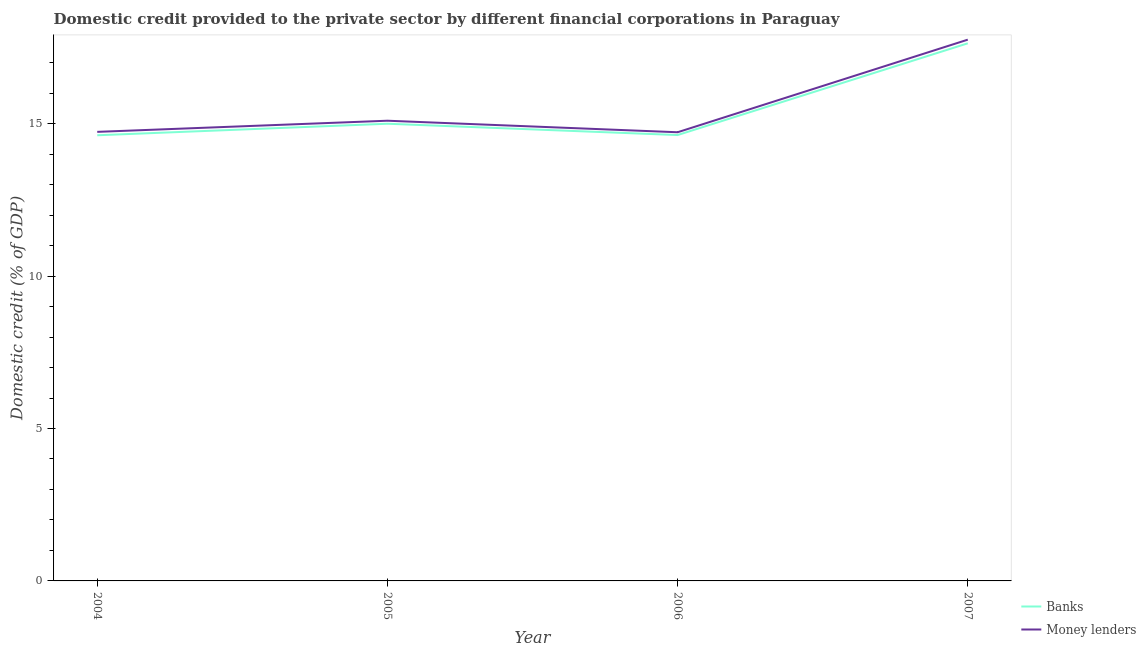How many different coloured lines are there?
Offer a very short reply. 2. Is the number of lines equal to the number of legend labels?
Your answer should be compact. Yes. What is the domestic credit provided by money lenders in 2005?
Offer a very short reply. 15.1. Across all years, what is the maximum domestic credit provided by money lenders?
Provide a succinct answer. 17.76. Across all years, what is the minimum domestic credit provided by money lenders?
Your answer should be compact. 14.72. What is the total domestic credit provided by banks in the graph?
Your answer should be compact. 61.88. What is the difference between the domestic credit provided by money lenders in 2004 and that in 2007?
Offer a very short reply. -3.02. What is the difference between the domestic credit provided by banks in 2004 and the domestic credit provided by money lenders in 2006?
Provide a short and direct response. -0.1. What is the average domestic credit provided by banks per year?
Provide a succinct answer. 15.47. In the year 2005, what is the difference between the domestic credit provided by money lenders and domestic credit provided by banks?
Provide a succinct answer. 0.1. What is the ratio of the domestic credit provided by banks in 2004 to that in 2007?
Make the answer very short. 0.83. Is the difference between the domestic credit provided by banks in 2005 and 2007 greater than the difference between the domestic credit provided by money lenders in 2005 and 2007?
Offer a very short reply. Yes. What is the difference between the highest and the second highest domestic credit provided by banks?
Give a very brief answer. 2.64. What is the difference between the highest and the lowest domestic credit provided by banks?
Make the answer very short. 3.02. Is the sum of the domestic credit provided by banks in 2004 and 2007 greater than the maximum domestic credit provided by money lenders across all years?
Ensure brevity in your answer.  Yes. Does the domestic credit provided by banks monotonically increase over the years?
Keep it short and to the point. No. Is the domestic credit provided by banks strictly less than the domestic credit provided by money lenders over the years?
Your response must be concise. Yes. How many years are there in the graph?
Ensure brevity in your answer.  4. What is the difference between two consecutive major ticks on the Y-axis?
Provide a succinct answer. 5. Are the values on the major ticks of Y-axis written in scientific E-notation?
Give a very brief answer. No. Does the graph contain any zero values?
Give a very brief answer. No. How many legend labels are there?
Your answer should be compact. 2. How are the legend labels stacked?
Your answer should be very brief. Vertical. What is the title of the graph?
Provide a short and direct response. Domestic credit provided to the private sector by different financial corporations in Paraguay. What is the label or title of the X-axis?
Your answer should be very brief. Year. What is the label or title of the Y-axis?
Make the answer very short. Domestic credit (% of GDP). What is the Domestic credit (% of GDP) of Banks in 2004?
Ensure brevity in your answer.  14.62. What is the Domestic credit (% of GDP) in Money lenders in 2004?
Your answer should be very brief. 14.73. What is the Domestic credit (% of GDP) of Banks in 2005?
Provide a short and direct response. 15. What is the Domestic credit (% of GDP) in Money lenders in 2005?
Give a very brief answer. 15.1. What is the Domestic credit (% of GDP) in Banks in 2006?
Offer a terse response. 14.63. What is the Domestic credit (% of GDP) in Money lenders in 2006?
Provide a succinct answer. 14.72. What is the Domestic credit (% of GDP) of Banks in 2007?
Ensure brevity in your answer.  17.64. What is the Domestic credit (% of GDP) of Money lenders in 2007?
Provide a succinct answer. 17.76. Across all years, what is the maximum Domestic credit (% of GDP) of Banks?
Your answer should be very brief. 17.64. Across all years, what is the maximum Domestic credit (% of GDP) of Money lenders?
Give a very brief answer. 17.76. Across all years, what is the minimum Domestic credit (% of GDP) in Banks?
Make the answer very short. 14.62. Across all years, what is the minimum Domestic credit (% of GDP) of Money lenders?
Give a very brief answer. 14.72. What is the total Domestic credit (% of GDP) in Banks in the graph?
Keep it short and to the point. 61.88. What is the total Domestic credit (% of GDP) in Money lenders in the graph?
Keep it short and to the point. 62.3. What is the difference between the Domestic credit (% of GDP) in Banks in 2004 and that in 2005?
Offer a very short reply. -0.38. What is the difference between the Domestic credit (% of GDP) in Money lenders in 2004 and that in 2005?
Offer a very short reply. -0.37. What is the difference between the Domestic credit (% of GDP) in Banks in 2004 and that in 2006?
Keep it short and to the point. -0.01. What is the difference between the Domestic credit (% of GDP) of Money lenders in 2004 and that in 2006?
Make the answer very short. 0.01. What is the difference between the Domestic credit (% of GDP) of Banks in 2004 and that in 2007?
Ensure brevity in your answer.  -3.02. What is the difference between the Domestic credit (% of GDP) in Money lenders in 2004 and that in 2007?
Your response must be concise. -3.02. What is the difference between the Domestic credit (% of GDP) of Banks in 2005 and that in 2006?
Your response must be concise. 0.37. What is the difference between the Domestic credit (% of GDP) of Money lenders in 2005 and that in 2006?
Make the answer very short. 0.38. What is the difference between the Domestic credit (% of GDP) of Banks in 2005 and that in 2007?
Provide a short and direct response. -2.64. What is the difference between the Domestic credit (% of GDP) of Money lenders in 2005 and that in 2007?
Your answer should be very brief. -2.66. What is the difference between the Domestic credit (% of GDP) in Banks in 2006 and that in 2007?
Provide a short and direct response. -3.01. What is the difference between the Domestic credit (% of GDP) in Money lenders in 2006 and that in 2007?
Your answer should be compact. -3.04. What is the difference between the Domestic credit (% of GDP) of Banks in 2004 and the Domestic credit (% of GDP) of Money lenders in 2005?
Your response must be concise. -0.48. What is the difference between the Domestic credit (% of GDP) of Banks in 2004 and the Domestic credit (% of GDP) of Money lenders in 2006?
Your answer should be compact. -0.1. What is the difference between the Domestic credit (% of GDP) in Banks in 2004 and the Domestic credit (% of GDP) in Money lenders in 2007?
Give a very brief answer. -3.14. What is the difference between the Domestic credit (% of GDP) of Banks in 2005 and the Domestic credit (% of GDP) of Money lenders in 2006?
Your answer should be compact. 0.28. What is the difference between the Domestic credit (% of GDP) of Banks in 2005 and the Domestic credit (% of GDP) of Money lenders in 2007?
Provide a succinct answer. -2.76. What is the difference between the Domestic credit (% of GDP) in Banks in 2006 and the Domestic credit (% of GDP) in Money lenders in 2007?
Give a very brief answer. -3.13. What is the average Domestic credit (% of GDP) in Banks per year?
Your response must be concise. 15.47. What is the average Domestic credit (% of GDP) of Money lenders per year?
Ensure brevity in your answer.  15.58. In the year 2004, what is the difference between the Domestic credit (% of GDP) in Banks and Domestic credit (% of GDP) in Money lenders?
Give a very brief answer. -0.11. In the year 2005, what is the difference between the Domestic credit (% of GDP) in Banks and Domestic credit (% of GDP) in Money lenders?
Your response must be concise. -0.1. In the year 2006, what is the difference between the Domestic credit (% of GDP) in Banks and Domestic credit (% of GDP) in Money lenders?
Provide a succinct answer. -0.09. In the year 2007, what is the difference between the Domestic credit (% of GDP) of Banks and Domestic credit (% of GDP) of Money lenders?
Provide a short and direct response. -0.12. What is the ratio of the Domestic credit (% of GDP) of Banks in 2004 to that in 2005?
Give a very brief answer. 0.97. What is the ratio of the Domestic credit (% of GDP) of Money lenders in 2004 to that in 2005?
Offer a very short reply. 0.98. What is the ratio of the Domestic credit (% of GDP) in Banks in 2004 to that in 2007?
Your answer should be compact. 0.83. What is the ratio of the Domestic credit (% of GDP) of Money lenders in 2004 to that in 2007?
Your answer should be compact. 0.83. What is the ratio of the Domestic credit (% of GDP) in Banks in 2005 to that in 2006?
Keep it short and to the point. 1.03. What is the ratio of the Domestic credit (% of GDP) of Money lenders in 2005 to that in 2006?
Your answer should be compact. 1.03. What is the ratio of the Domestic credit (% of GDP) in Banks in 2005 to that in 2007?
Provide a short and direct response. 0.85. What is the ratio of the Domestic credit (% of GDP) of Money lenders in 2005 to that in 2007?
Your answer should be very brief. 0.85. What is the ratio of the Domestic credit (% of GDP) in Banks in 2006 to that in 2007?
Your response must be concise. 0.83. What is the ratio of the Domestic credit (% of GDP) in Money lenders in 2006 to that in 2007?
Your answer should be compact. 0.83. What is the difference between the highest and the second highest Domestic credit (% of GDP) in Banks?
Your answer should be compact. 2.64. What is the difference between the highest and the second highest Domestic credit (% of GDP) of Money lenders?
Make the answer very short. 2.66. What is the difference between the highest and the lowest Domestic credit (% of GDP) of Banks?
Offer a very short reply. 3.02. What is the difference between the highest and the lowest Domestic credit (% of GDP) of Money lenders?
Provide a succinct answer. 3.04. 